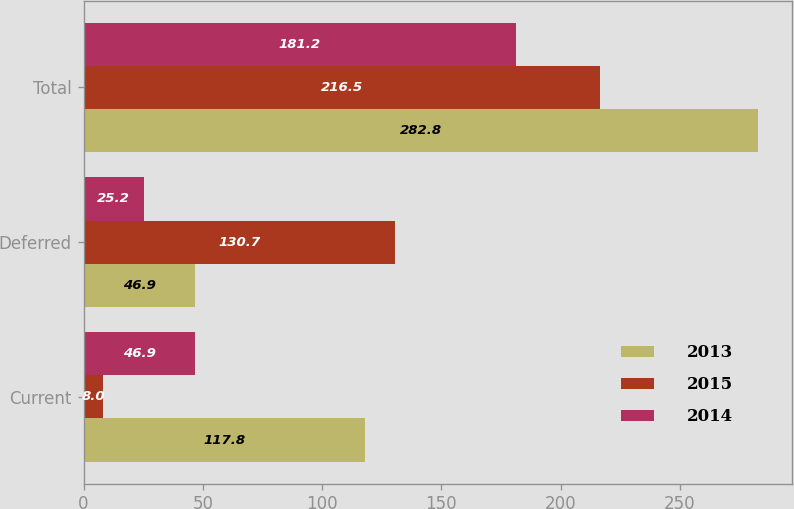Convert chart. <chart><loc_0><loc_0><loc_500><loc_500><stacked_bar_chart><ecel><fcel>Current<fcel>Deferred<fcel>Total<nl><fcel>2013<fcel>117.8<fcel>46.9<fcel>282.8<nl><fcel>2015<fcel>8<fcel>130.7<fcel>216.5<nl><fcel>2014<fcel>46.9<fcel>25.2<fcel>181.2<nl></chart> 